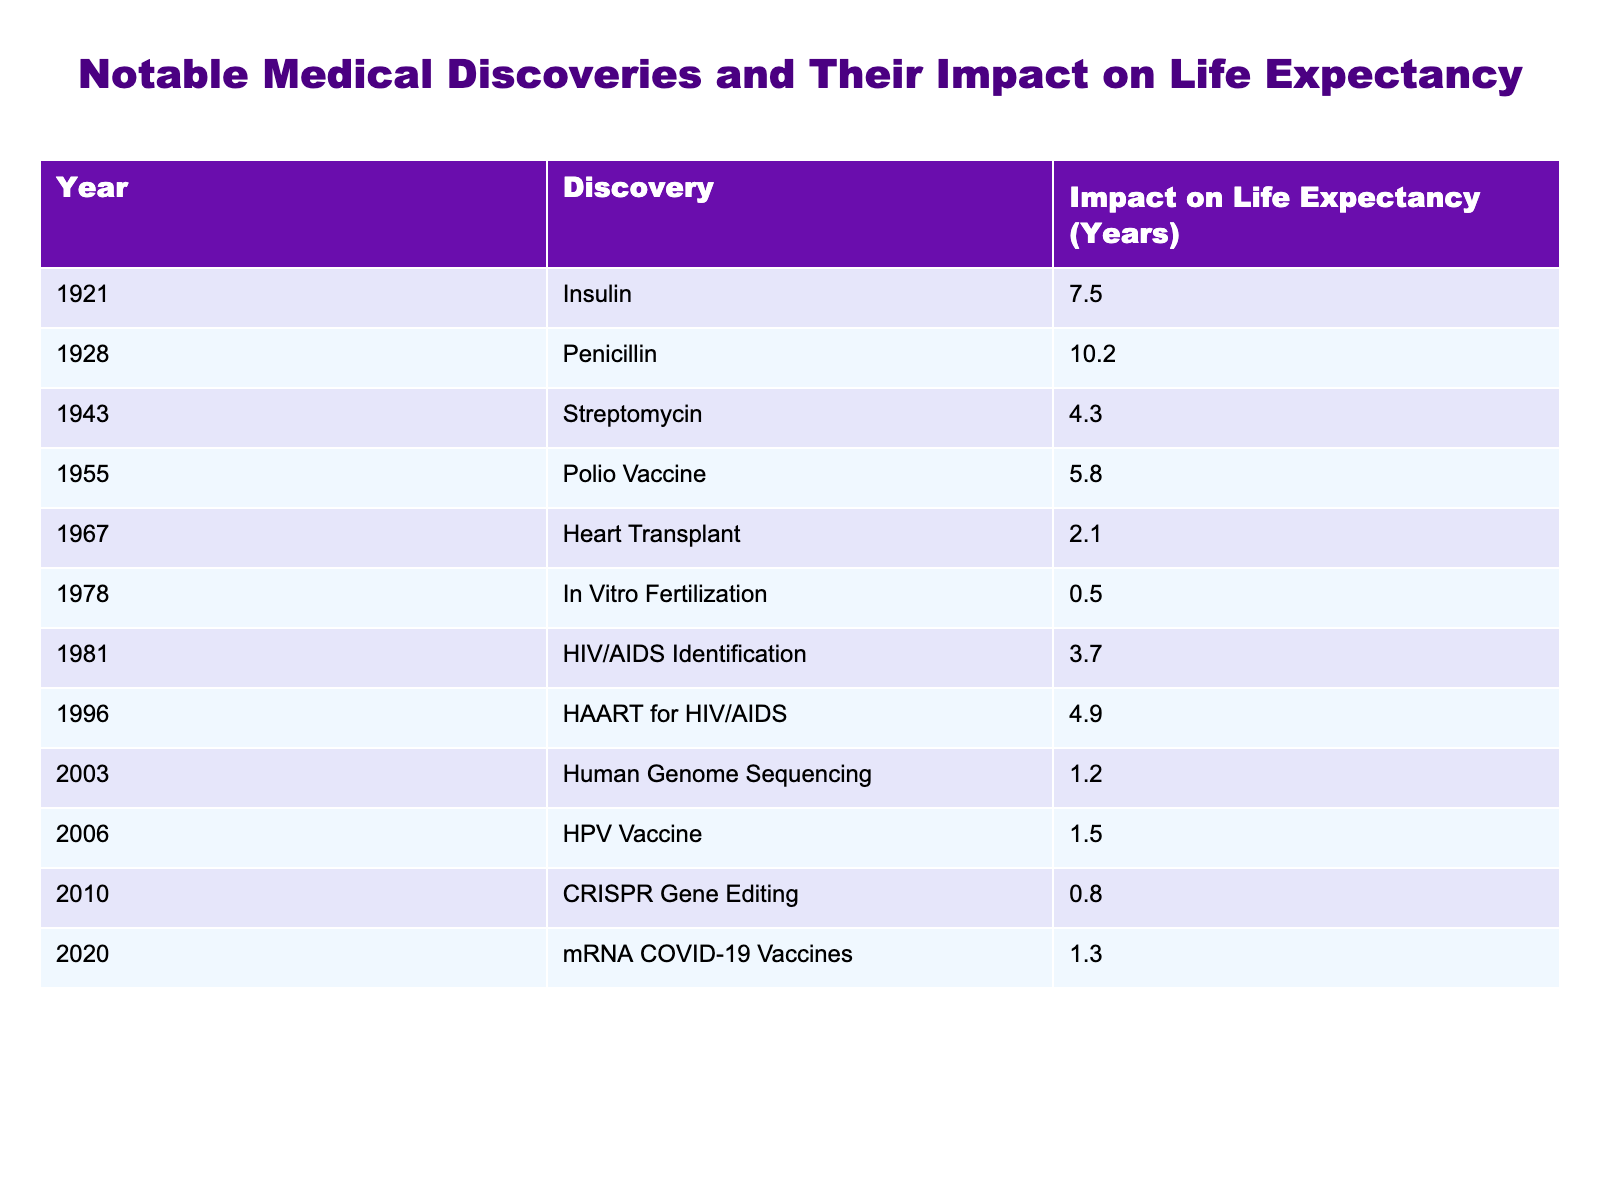What was the impact of the Polio Vaccine on life expectancy? According to the table, the Polio Vaccine, which was discovered in 1955, had an impact of 5.8 years on life expectancy.
Answer: 5.8 years Which medical discovery had the highest impact on life expectancy? By examining the impact values listed in the table, Penicillin had the highest impact with 10.2 years.
Answer: Penicillin What is the average impact on life expectancy of the medical discoveries listed after the year 2000? The discoveries after 2000 are Human Genome Sequencing (1.2), HPV Vaccine (1.5), CRISPR Gene Editing (0.8), and mRNA COVID-19 Vaccines (1.3). Their total impact is 1.2 + 1.5 + 0.8 + 1.3 = 4.8. There are 4 discoveries, so the average is 4.8 / 4 = 1.2.
Answer: 1.2 years Did the introduction of the HIV/AIDS Identification in 1981 significantly enhance life expectancy compared to the Heart Transplant in 1967? The impact of HIV/AIDS Identification (3.7 years) is greater than that of the Heart Transplant (2.1 years). Therefore, yes, it did enhance life expectancy significantly more.
Answer: Yes What was the difference in the impact on life expectancy between Insulin and HAART for HIV/AIDS? The impact of Insulin is 7.5 years, while HAART for HIV/AIDS is 4.9 years. The difference is 7.5 - 4.9 = 2.6 years.
Answer: 2.6 years Which discovery had the least impact on life expectancy and in what year was it introduced? According to the table, the least impact is from In Vitro Fertilization, which is 0.5 years, and it was introduced in 1978.
Answer: In Vitro Fertilization, 0.5 years, 1978 Are the impacts on life expectancy for discoveries before 1945 generally greater or less than those after 1945? The total impact of discoveries before 1945 (Insulin: 7.5 + Penicillin: 10.2 + Streptomycin: 4.3 = 22.0) is greater than those after 1945 (Heart Transplant: 2.1 + In Vitro Fertilization: 0.5 + HIV/AIDS Identification: 3.7 + HAART: 4.9 + Human Genome Sequencing: 1.2 + HPV Vaccine: 1.5 + CRISPR: 0.8 + mRNA COVID-19 Vaccines: 1.3 = 16.0). Thus, discoveries before 1945 have a greater impact.
Answer: Greater What percentage of the total impact on life expectancy does the Polio Vaccine represent? The total impact is calculated by summing all discoveries: 7.5 + 10.2 + 4.3 + 5.8 + 2.1 + 0.5 + 3.7 + 4.9 + 1.2 + 1.5 + 0.8 + 1.3 = 58.5 years. The Polio Vaccine impact is 5.8 years. Thus, the percentage is (5.8 / 58.5) * 100 ≈ 9.91%.
Answer: Approximately 9.91% 